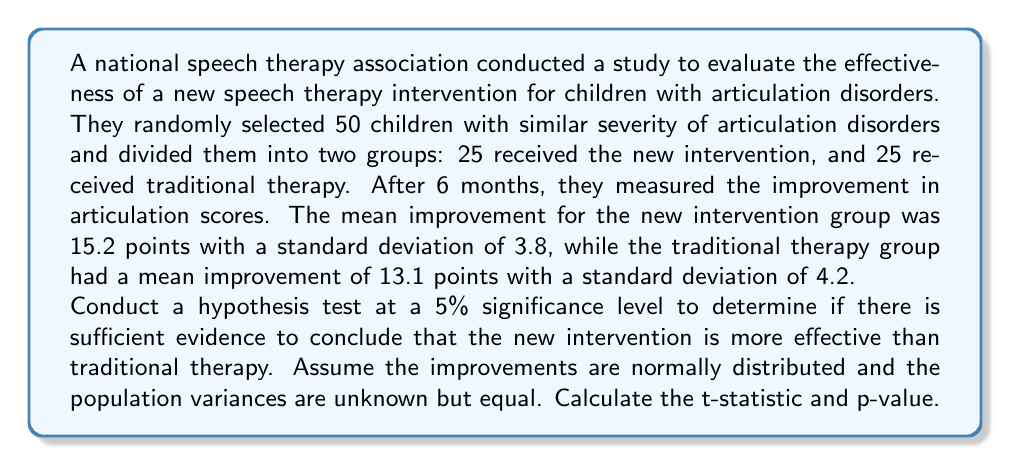Give your solution to this math problem. To conduct this hypothesis test, we'll follow these steps:

1. State the hypotheses:
   $H_0: \mu_1 - \mu_2 = 0$ (no difference between interventions)
   $H_a: \mu_1 - \mu_2 > 0$ (new intervention is more effective)

2. Choose the significance level: $\alpha = 0.05$

3. Calculate the pooled standard deviation:
   $$s_p = \sqrt{\frac{(n_1 - 1)s_1^2 + (n_2 - 1)s_2^2}{n_1 + n_2 - 2}}$$
   $$s_p = \sqrt{\frac{(25 - 1)(3.8)^2 + (25 - 1)(4.2)^2}{25 + 25 - 2}} = 4.0050$$

4. Calculate the t-statistic:
   $$t = \frac{(\bar{x}_1 - \bar{x}_2) - (\mu_1 - \mu_2)}{s_p\sqrt{\frac{1}{n_1} + \frac{1}{n_2}}}$$
   $$t = \frac{(15.2 - 13.1) - 0}{4.0050\sqrt{\frac{1}{25} + \frac{1}{25}}} = 1.8647$$

5. Calculate degrees of freedom:
   $df = n_1 + n_2 - 2 = 25 + 25 - 2 = 48$

6. Find the p-value:
   Using a t-distribution table or calculator, we find:
   $p-value = P(T > 1.8647) = 0.0341$

7. Make a decision:
   Since $p-value = 0.0341 < \alpha = 0.05$, we reject the null hypothesis.

8. State the conclusion:
   There is sufficient evidence to conclude that the new intervention is more effective than traditional therapy at the 5% significance level.
Answer: $t = 1.8647$, $p-value = 0.0341$ 